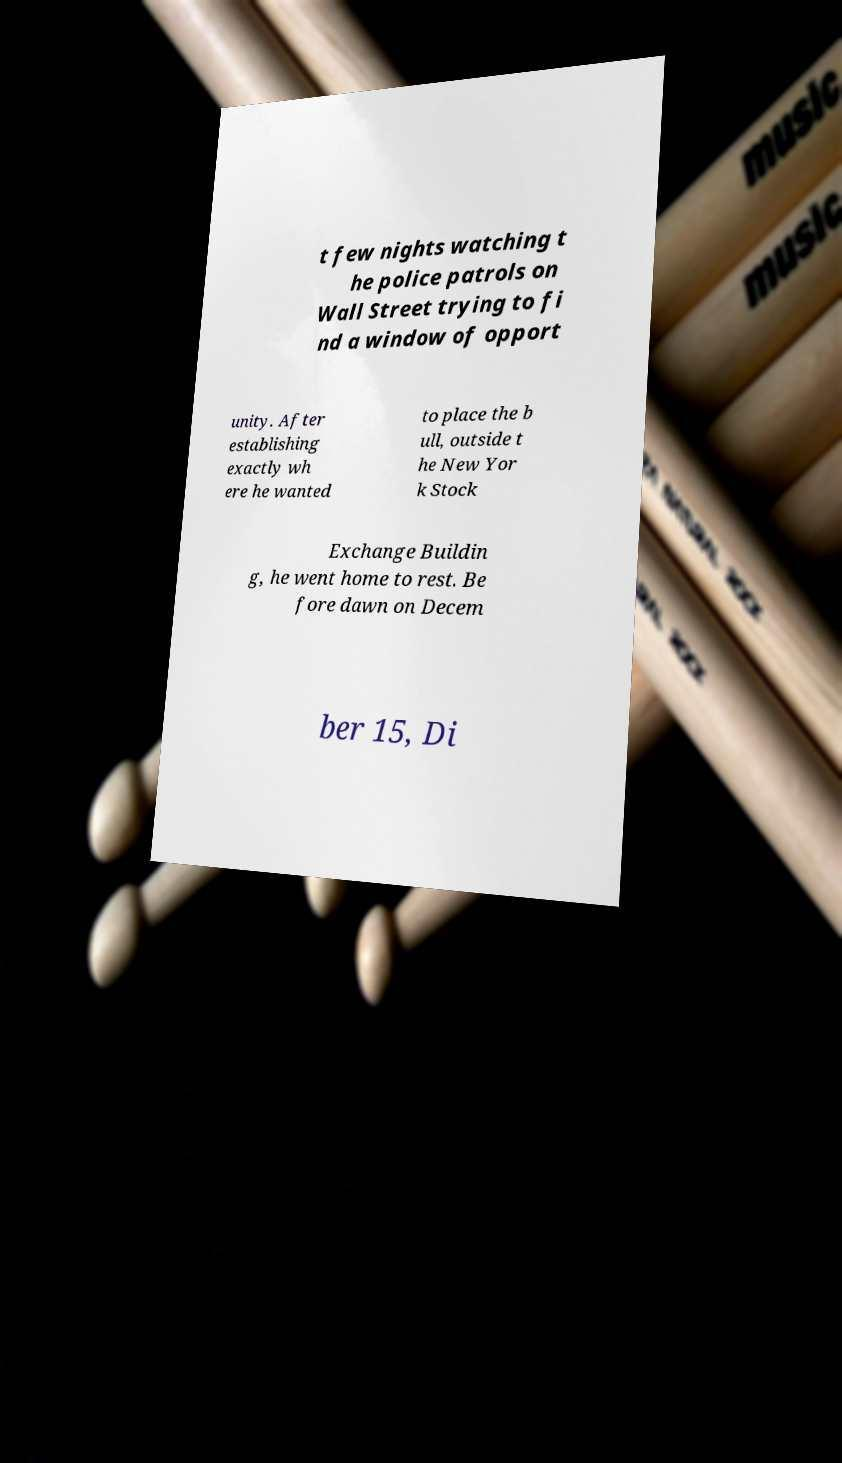For documentation purposes, I need the text within this image transcribed. Could you provide that? t few nights watching t he police patrols on Wall Street trying to fi nd a window of opport unity. After establishing exactly wh ere he wanted to place the b ull, outside t he New Yor k Stock Exchange Buildin g, he went home to rest. Be fore dawn on Decem ber 15, Di 